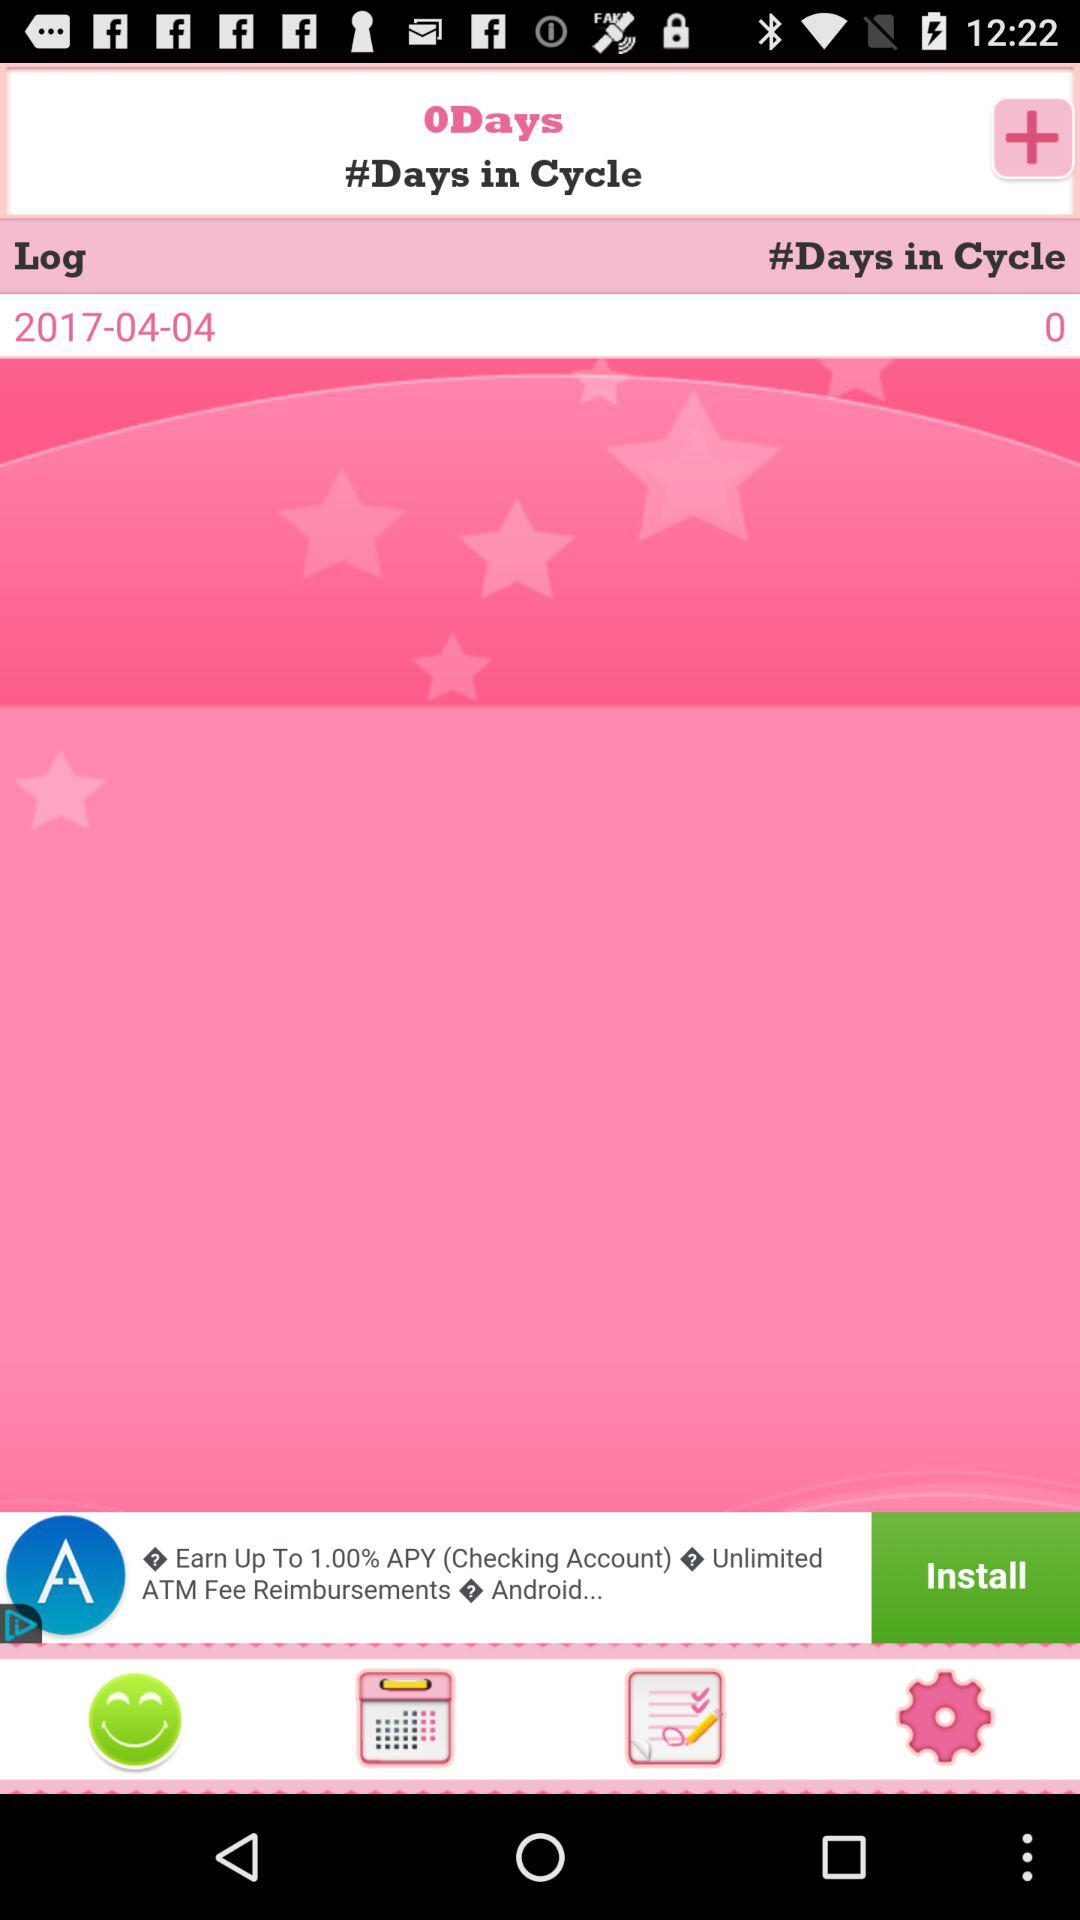What is the mentioned date? The mentioned date is April 04, 2017. 